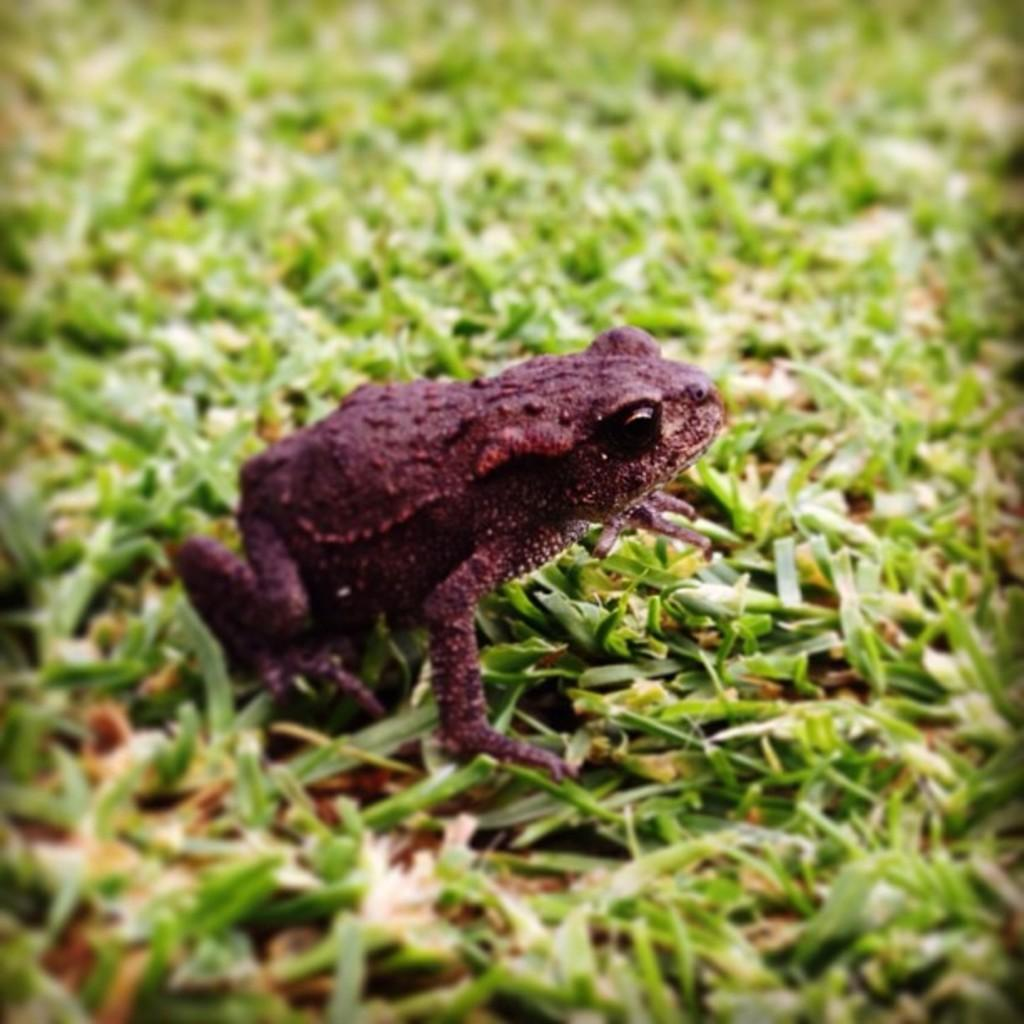What type of animal is in the image? There is a frog in the image. What color is the frog? The frog is brown in color. What is the frog sitting on in the image? The frog is on green grass. What type of shoe is the frog wearing in the image? There is no shoe present in the image, as the frog is an amphibian and does not wear shoes. 